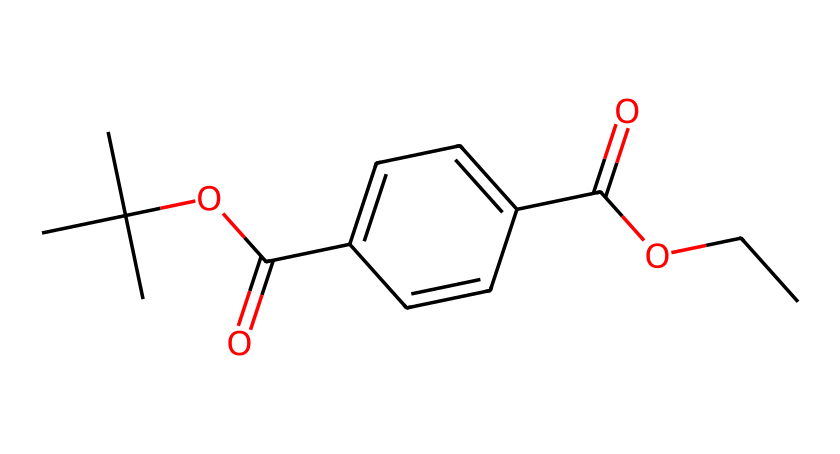what is the main functional group present in this molecule? The structure includes a carboxylic acid group (–COOH) indicated by the carbon double bonded to oxygen and single bonded to a hydroxyl group (–OH). This is characteristic of the polymer's esterification process within PET.
Answer: carboxylic acid how many carbon atoms are present in this molecule? Counting the carbon atoms in the provided SMILES representation, there are 10 carbon atoms in total: 8 from the backbone and 2 from the ester groups.
Answer: 10 does this molecule include any aromatic rings? The presence of "c" in the SMILES indicates the presence of aromatic rings. In this case, the "c1ccc(cc1)" indicates one aromatic ring in the structure of PET.
Answer: yes which part of the molecule determines its plastic properties? The long hydrocarbon chains formed by the repeating units through ester linkages contribute to the plastic-like properties of PET, allowing for flexibility and durability.
Answer: hydrocarbon chains what is the significance of the ester bonds in polyethylene terephthalate? The ester bonds (–COO–) in PET are crucial as they form the backbone of the polymer chain, allowing it to have thermoplastic properties which are essential in manufacturing plastics, contributing to recycling capabilities.
Answer: polymer backbone 